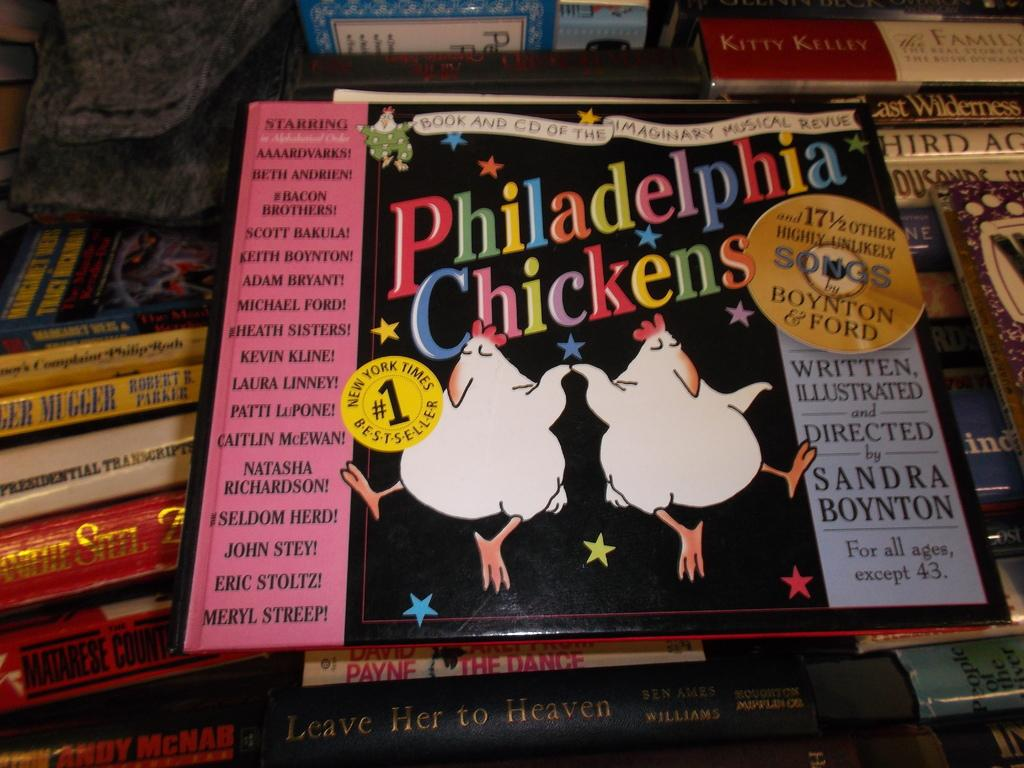<image>
Provide a brief description of the given image. A CD with titled Philadelphia Chickens by Boynton and Ford. 